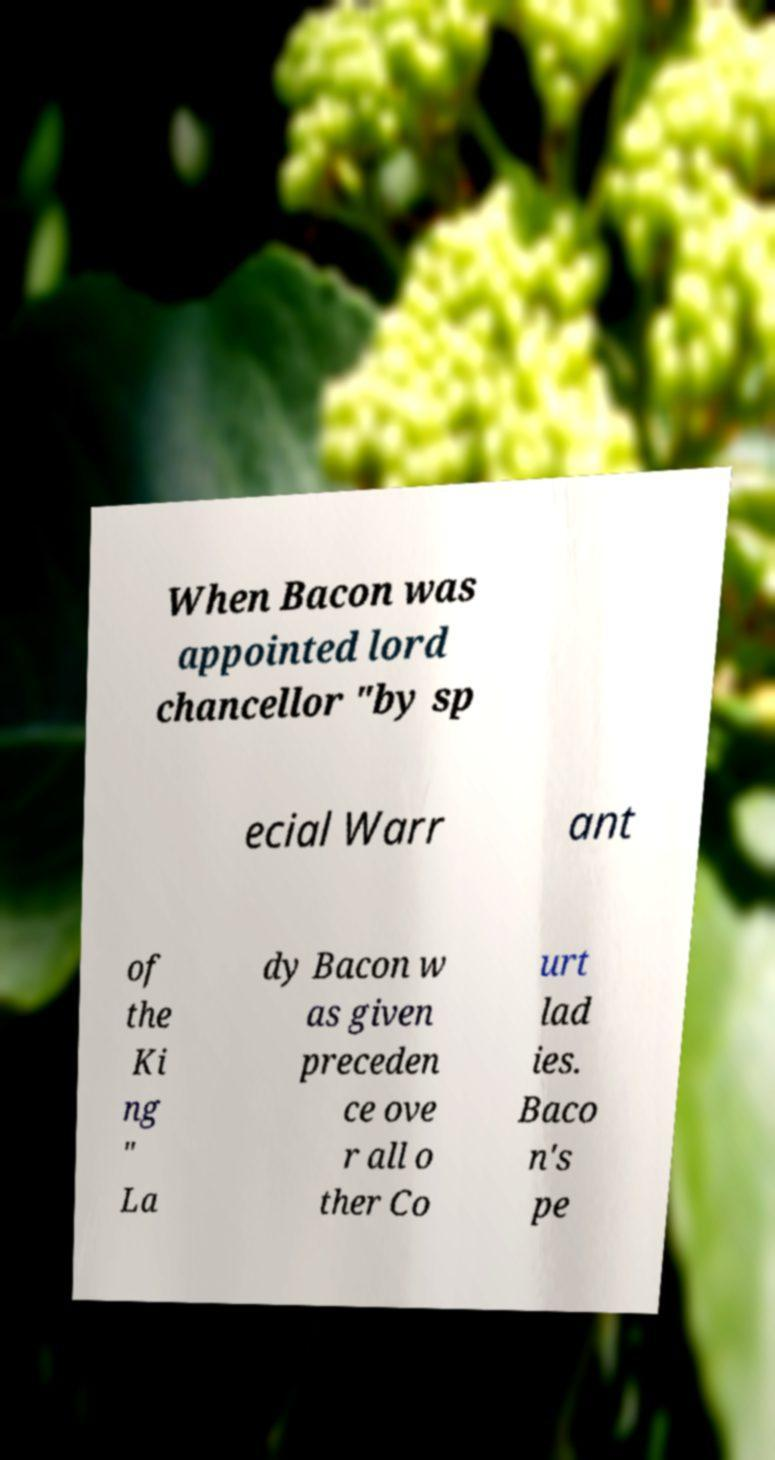What messages or text are displayed in this image? I need them in a readable, typed format. When Bacon was appointed lord chancellor "by sp ecial Warr ant of the Ki ng " La dy Bacon w as given preceden ce ove r all o ther Co urt lad ies. Baco n's pe 